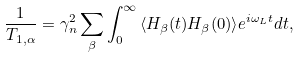<formula> <loc_0><loc_0><loc_500><loc_500>\frac { 1 } { T _ { 1 , { \alpha } } } = \gamma _ { n } ^ { 2 } \sum _ { \beta } \int _ { 0 } ^ { \infty } { \langle H _ { \beta } ( t ) H _ { \beta } ( 0 ) \rangle e ^ { i \omega _ { L } t } } d t ,</formula> 